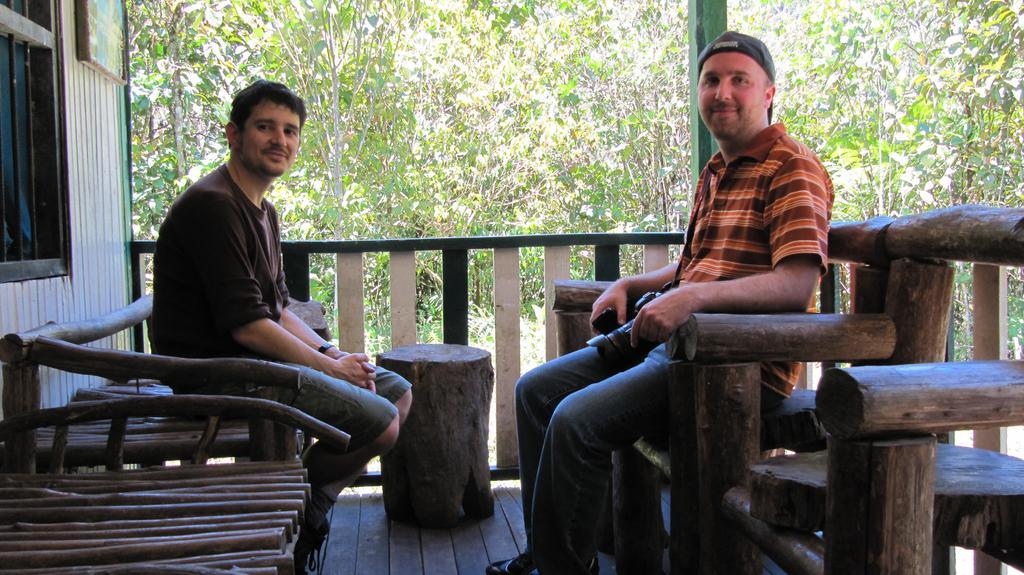Can you describe this image briefly? In this image we can see two persons smiling and sitting on the bamboo chairs. On the left there is a window and there is also a frame to the wall. In the background we can see many trees. 